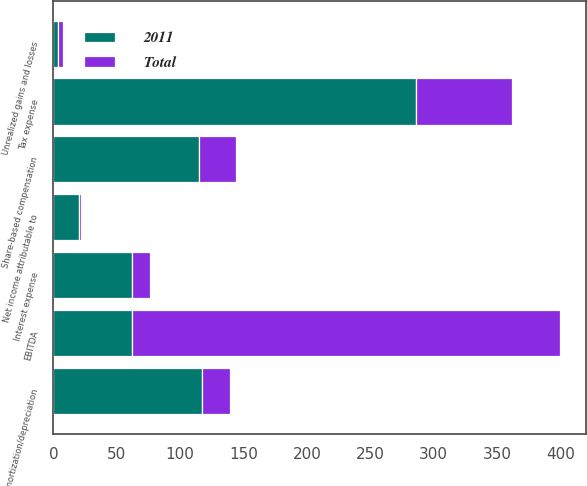<chart> <loc_0><loc_0><loc_500><loc_500><stacked_bar_chart><ecel><fcel>Net income attributable to<fcel>Tax expense<fcel>Amortization/depreciation<fcel>Interest expense<fcel>Share-based compensation<fcel>Unrealized gains and losses<fcel>EBITDA<nl><fcel>2011<fcel>20.2<fcel>286.1<fcel>117.4<fcel>61.8<fcel>115.1<fcel>3.6<fcel>61.8<nl><fcel>Total<fcel>1.9<fcel>76<fcel>22.1<fcel>14.3<fcel>29.1<fcel>3.8<fcel>338.1<nl></chart> 